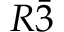<formula> <loc_0><loc_0><loc_500><loc_500>R \bar { 3 }</formula> 